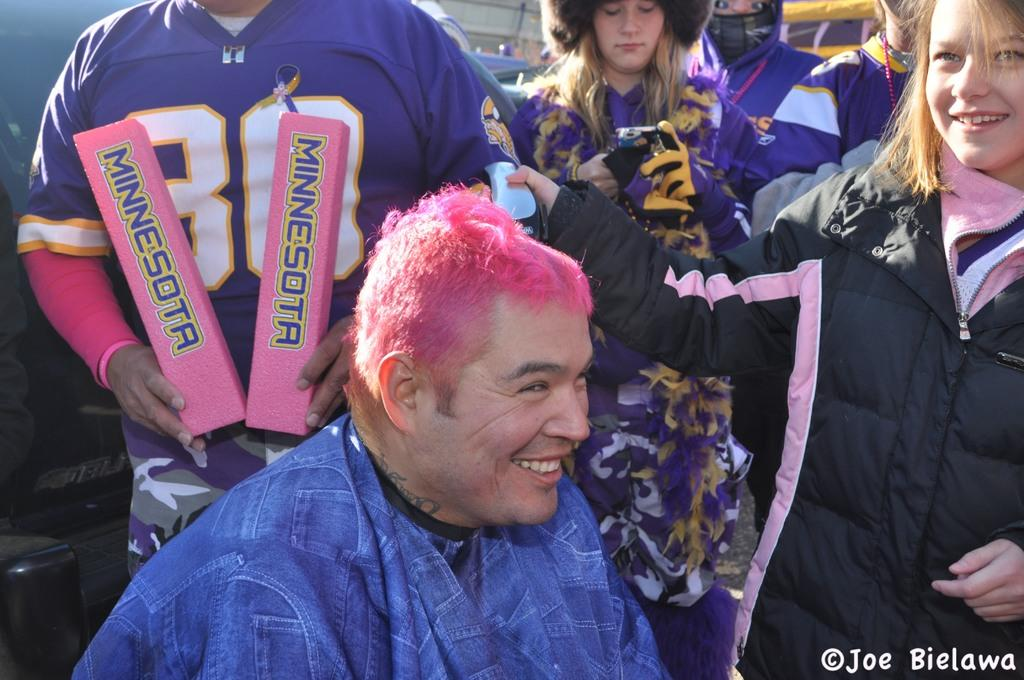<image>
Give a short and clear explanation of the subsequent image. A group of Minnesota Viking football fans outside of the stadium supporting breast cancer awareness. 